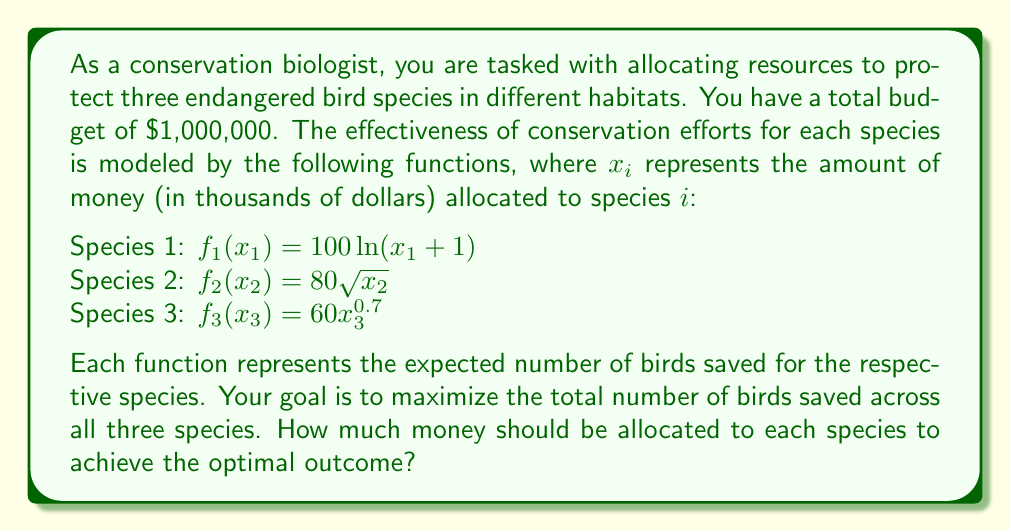What is the answer to this math problem? To solve this problem, we'll use the method of Lagrange multipliers, which is ideal for optimizing constrained problems like this one.

1) First, let's define our objective function and constraint:

   Maximize: $F(x_1, x_2, x_3) = 100\ln(x_1 + 1) + 80\sqrt{x_2} + 60x_3^{0.7}$
   Subject to: $x_1 + x_2 + x_3 = 1000$ (since $x_i$ is in thousands of dollars)

2) We form the Lagrangian function:

   $L(x_1, x_2, x_3, \lambda) = 100\ln(x_1 + 1) + 80\sqrt{x_2} + 60x_3^{0.7} - \lambda(x_1 + x_2 + x_3 - 1000)$

3) Now, we take partial derivatives and set them equal to zero:

   $\frac{\partial L}{\partial x_1} = \frac{100}{x_1 + 1} - \lambda = 0$
   $\frac{\partial L}{\partial x_2} = \frac{40}{\sqrt{x_2}} - \lambda = 0$
   $\frac{\partial L}{\partial x_3} = \frac{42}{x_3^{0.3}} - \lambda = 0$
   $\frac{\partial L}{\partial \lambda} = x_1 + x_2 + x_3 - 1000 = 0$

4) From these equations, we can derive:

   $x_1 + 1 = \frac{100}{\lambda}$
   $x_2 = (\frac{40}{\lambda})^2$
   $x_3 = (\frac{42}{\lambda})^{\frac{10}{3}}$

5) Substituting these into the constraint equation:

   $(\frac{100}{\lambda} - 1) + (\frac{40}{\lambda})^2 + (\frac{42}{\lambda})^{\frac{10}{3}} = 1000$

6) This equation can be solved numerically to find $\lambda \approx 0.1$

7) Substituting this value back into our expressions for $x_1$, $x_2$, and $x_3$:

   $x_1 \approx 999$
   $x_2 \approx 160000$
   $x_3 \approx 839841$

8) Adjusting for the fact that these are in thousands of dollars and rounding to the nearest dollar:

   Species 1: $399,000
   Species 2: $160,000
   Species 3: $441,000
Answer: The optimal allocation of the $1,000,000 budget is:
Species 1: $399,000
Species 2: $160,000
Species 3: $441,000 